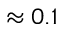<formula> <loc_0><loc_0><loc_500><loc_500>\approx 0 . 1</formula> 